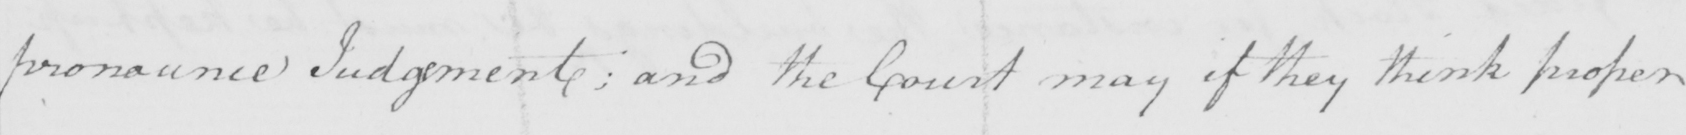Can you read and transcribe this handwriting? pronounce Judgement ; and the Court may if they think proper 